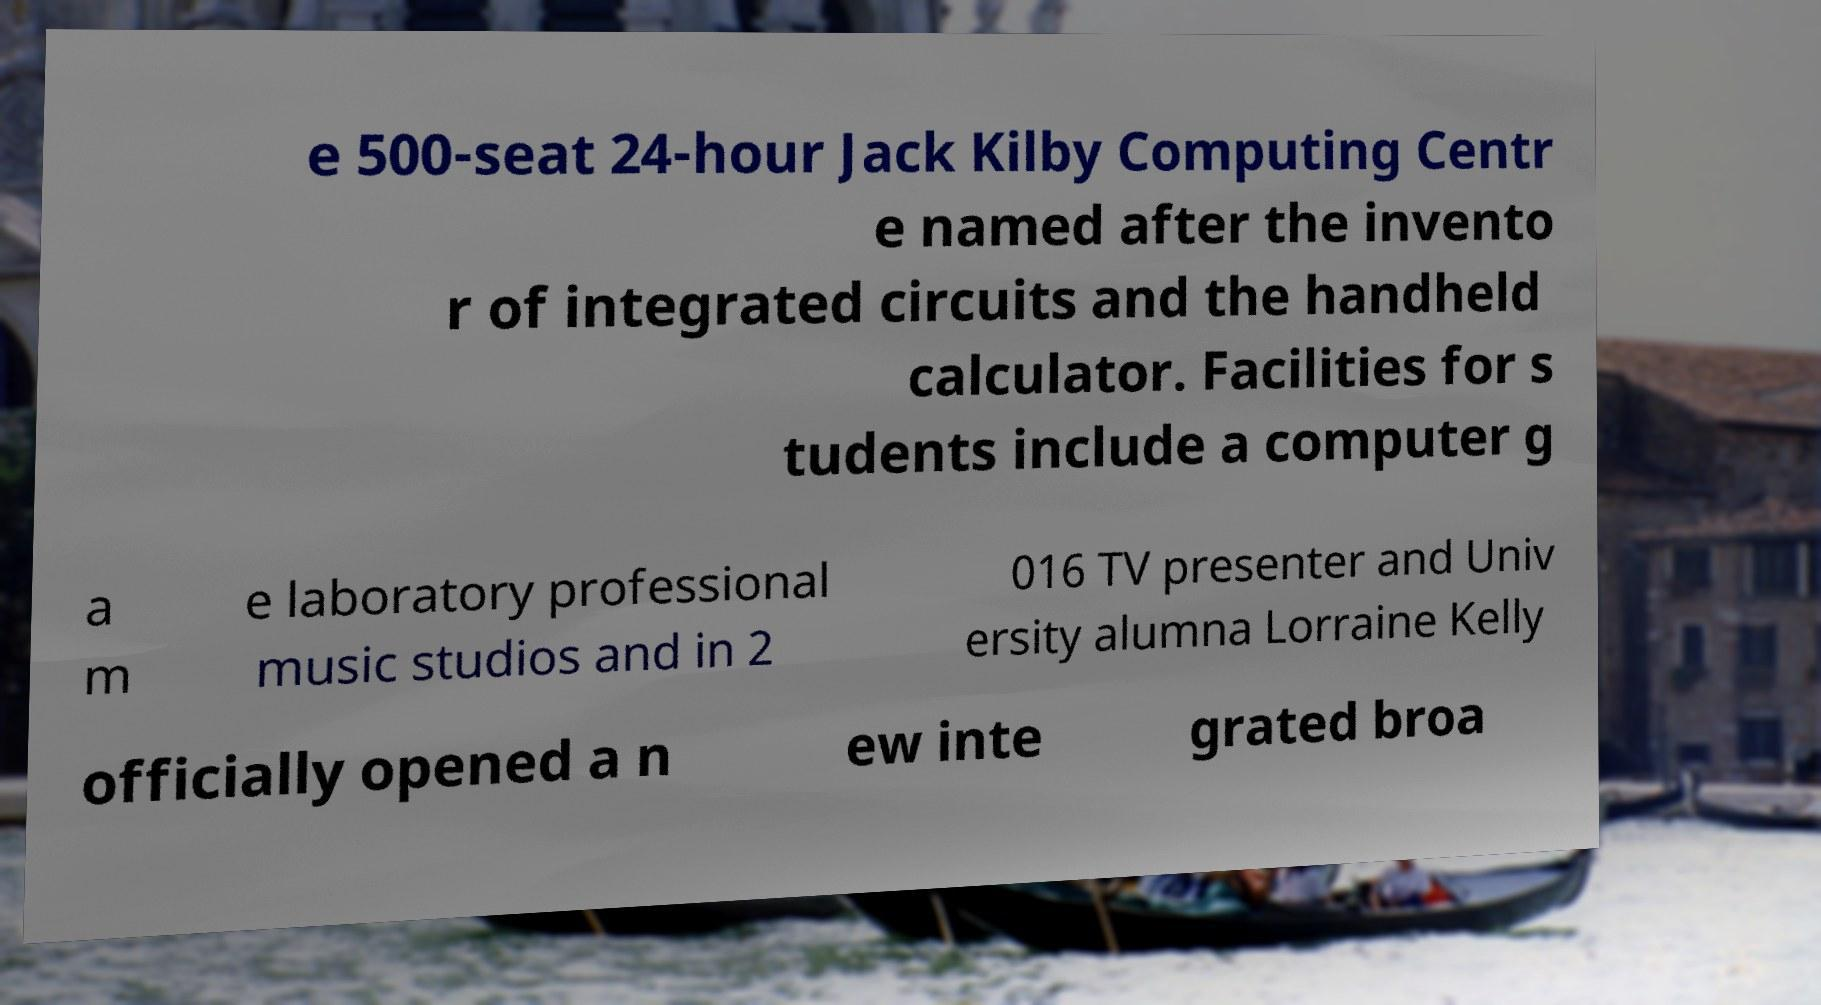Could you assist in decoding the text presented in this image and type it out clearly? e 500-seat 24-hour Jack Kilby Computing Centr e named after the invento r of integrated circuits and the handheld calculator. Facilities for s tudents include a computer g a m e laboratory professional music studios and in 2 016 TV presenter and Univ ersity alumna Lorraine Kelly officially opened a n ew inte grated broa 